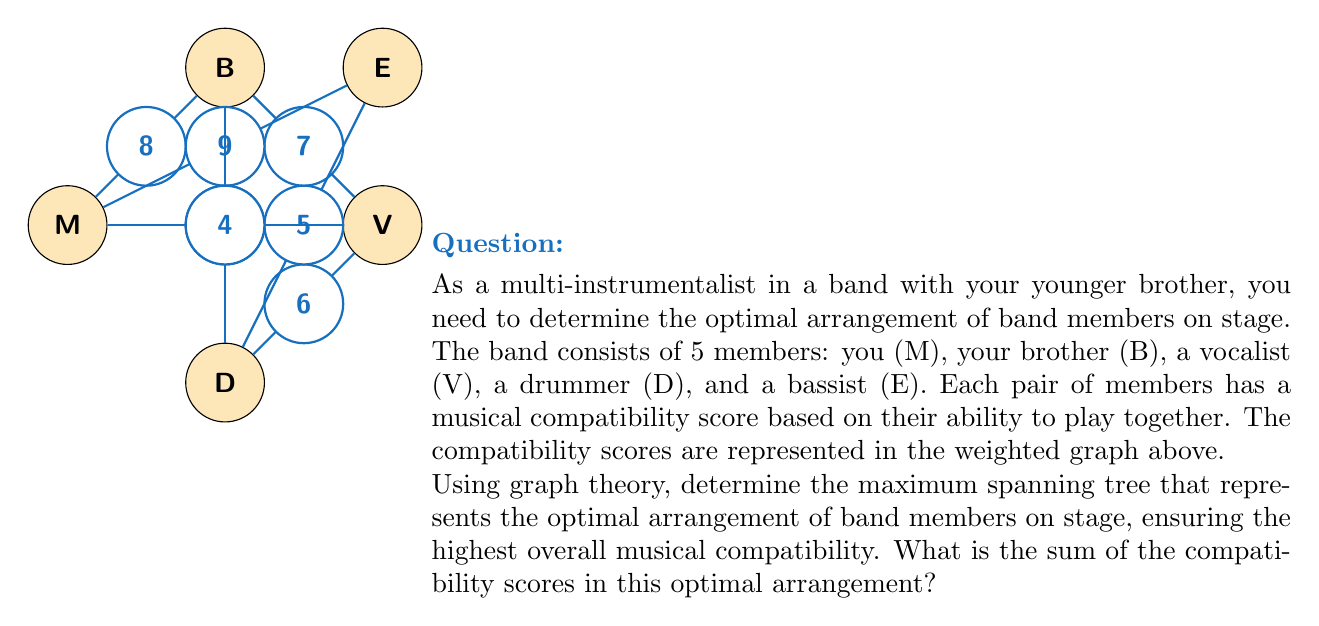What is the answer to this math problem? To solve this problem, we need to find the maximum spanning tree of the given weighted graph. The maximum spanning tree will give us the arrangement that maximizes the overall musical compatibility between band members.

We can use Kruskal's algorithm, but instead of selecting the minimum weight edges, we'll select the maximum weight edges:

1. Sort the edges by weight in descending order:
   (E,A): 9
   (M,B): 8
   (B,V): 7
   (M,V): 6
   (V,D): 6
   (D,E): 5
   (B,D): 4

2. Start adding edges to the tree, ensuring no cycles are formed:
   - Add (E,A): 9
   - Add (M,B): 8
   - Add (B,V): 7
   - Add (V,D): 6 (we choose V-D over M-V to avoid creating a cycle)

3. The maximum spanning tree is now complete with 4 edges (for 5 vertices).

The edges in the maximum spanning tree are:
1. (E,A) with weight 9
2. (M,B) with weight 8
3. (B,V) with weight 7
4. (V,D) with weight 6

The sum of the compatibility scores in this optimal arrangement is:
$$9 + 8 + 7 + 6 = 30$$

This arrangement ensures that each band member is connected to others with the highest possible compatibility scores, maximizing the overall musical synergy on stage.
Answer: 30 